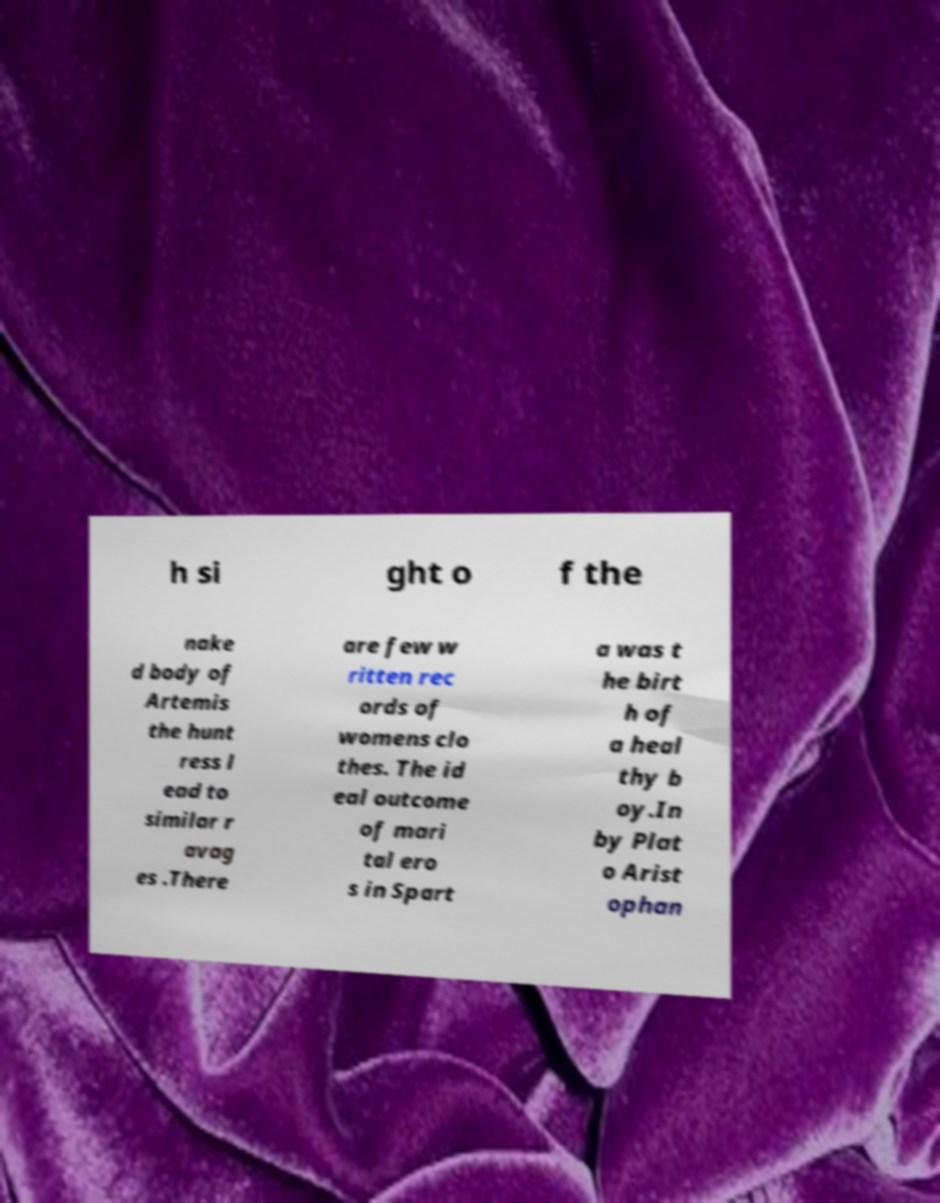There's text embedded in this image that I need extracted. Can you transcribe it verbatim? h si ght o f the nake d body of Artemis the hunt ress l ead to similar r avag es .There are few w ritten rec ords of womens clo thes. The id eal outcome of mari tal ero s in Spart a was t he birt h of a heal thy b oy.In by Plat o Arist ophan 